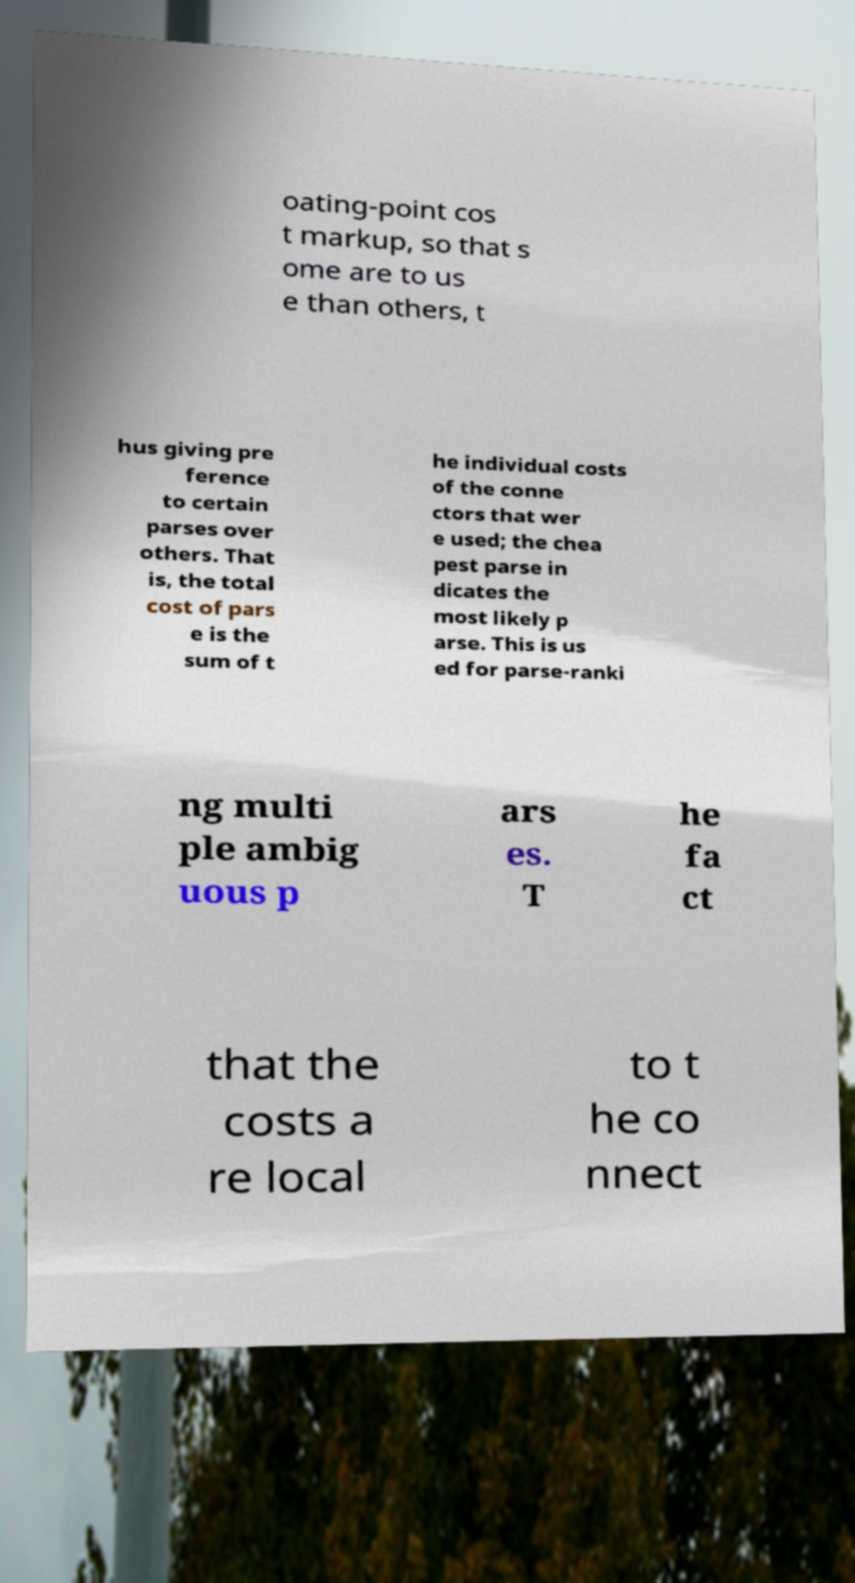Please read and relay the text visible in this image. What does it say? oating-point cos t markup, so that s ome are to us e than others, t hus giving pre ference to certain parses over others. That is, the total cost of pars e is the sum of t he individual costs of the conne ctors that wer e used; the chea pest parse in dicates the most likely p arse. This is us ed for parse-ranki ng multi ple ambig uous p ars es. T he fa ct that the costs a re local to t he co nnect 